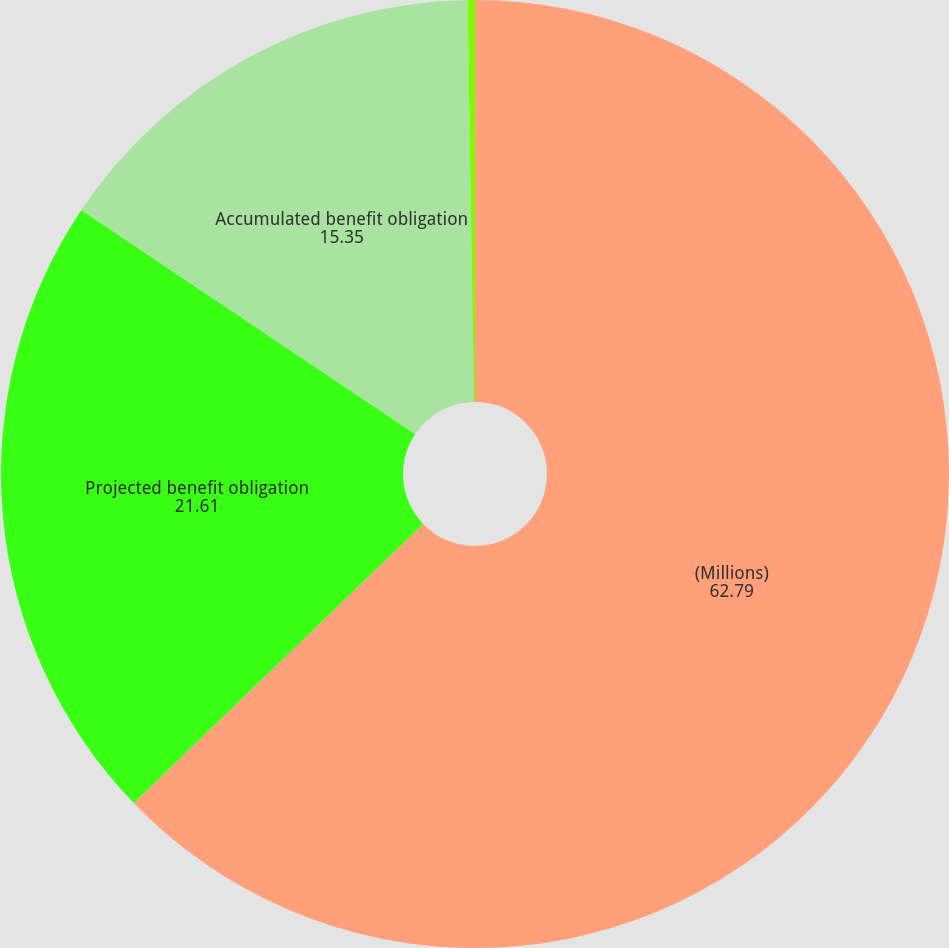<chart> <loc_0><loc_0><loc_500><loc_500><pie_chart><fcel>(Millions)<fcel>Projected benefit obligation<fcel>Accumulated benefit obligation<fcel>Fair value of plan assets<nl><fcel>62.79%<fcel>21.61%<fcel>15.35%<fcel>0.25%<nl></chart> 